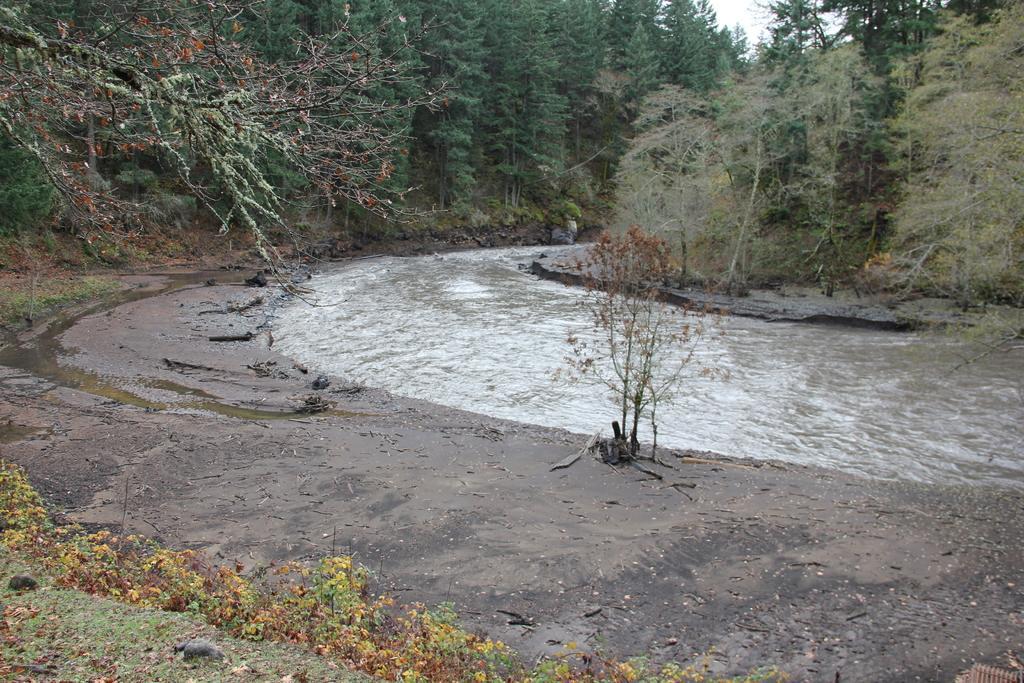How would you summarize this image in a sentence or two? In this image we can see some trees, bushes, plants and grass on the surface. There is one river, some stones, one object on the surface and at the top there is the sky. 